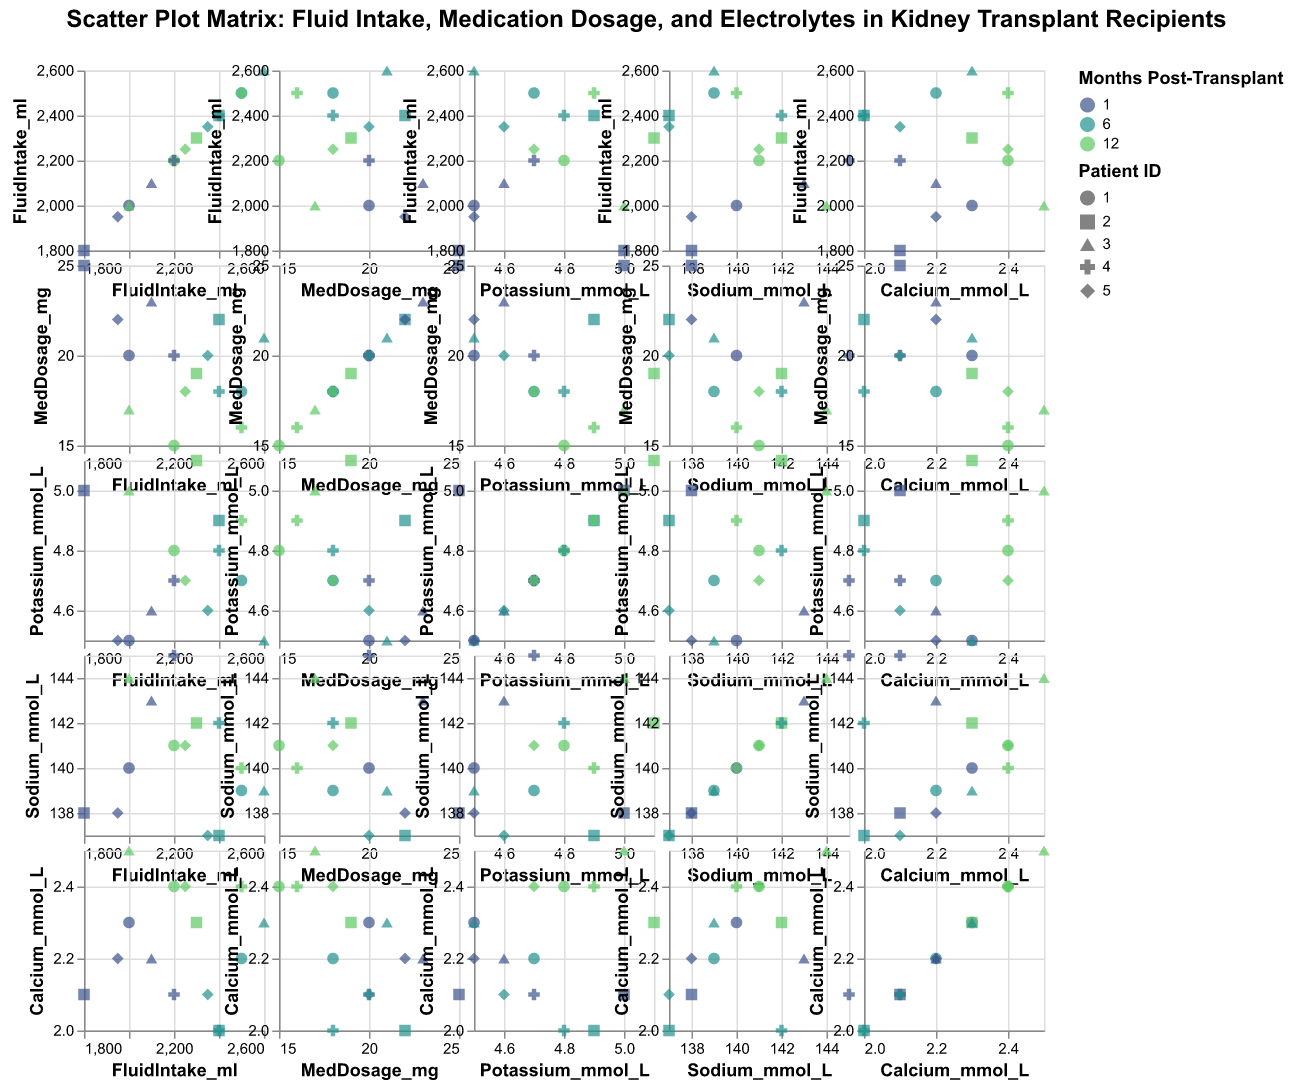How many data points represent patients who are 1 month post-transplant? By observing the color legend (Months Post-Transplant) and looking for the corresponding color indicator for 1 month, we can count the number of data points across all scatter plots with this color
Answer: 5 Which patient has the highest fluid intake 6 months post-transplant? By focusing on the data points where the fluid intake is plotted against months post-transplant and locating the highest fluid intake value colored for 6 months, we identify the corresponding shape representing the patient ID from the legend
Answer: Patient ID 3 Do potassium levels increase or decrease over time post-transplant? By identifying the data points in the scatter plots where Potassium levels are plotted against months post-transplant, observe the general trend of data points from month 1 to month 12
Answer: Generally increase Which two variables have a clearly positive correlation? By examining each scatter plot in the SPLOM and identifying which pair of variables has data points forming an upward trajectory or diagonal
Answer: Fluid Intake and Months Post-Transplant What is the correlation between medication dosage and calcium levels? By examining the scatter plot of Medication Dosage vs. Calcium levels, look for patterns such as upward or downward trajectories or lack thereof
Answer: Weak negative correlation For Patient 4, what is the trend of sodium levels over the months? Locate the data points for Patient 4 (shape in legend) in scatter plots involving Sodium Levels vs. Months Post-Transplant, and observe the direction of data points over time
Answer: Decreasing trend Are any electrolyte levels notably stable across months post-transplant? Examine each scatter plot matrix for electrolyte levels (Potassium, Sodium, Calcium) against months post-transplant and see if data points show minimal variation over time
Answer: Sodium and Calcium are relatively stable Is there any patient with consistently high medication dosages throughout the 12 months? Check the data points for each patient in columns for Medication Dosage across all chart types to identify a patient whose data remains on the higher side consistently
Answer: Patient ID 2 Which variable shows the greatest variability across the patients over time? Look for scatter plots where the spread of data points is the widest for any variable on either axis, indicating higher variability
Answer: Fluid Intake 